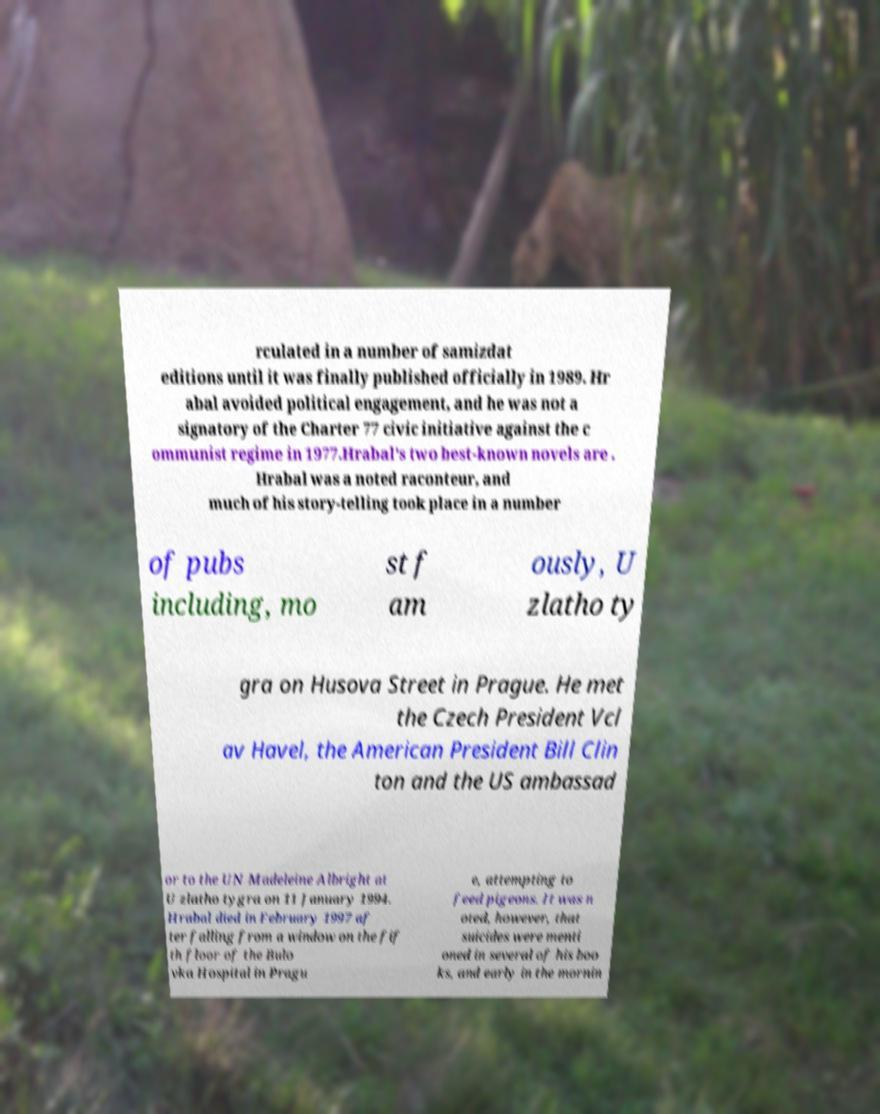Could you assist in decoding the text presented in this image and type it out clearly? rculated in a number of samizdat editions until it was finally published officially in 1989. Hr abal avoided political engagement, and he was not a signatory of the Charter 77 civic initiative against the c ommunist regime in 1977.Hrabal's two best-known novels are . Hrabal was a noted raconteur, and much of his story-telling took place in a number of pubs including, mo st f am ously, U zlatho ty gra on Husova Street in Prague. He met the Czech President Vcl av Havel, the American President Bill Clin ton and the US ambassad or to the UN Madeleine Albright at U zlatho tygra on 11 January 1994. Hrabal died in February 1997 af ter falling from a window on the fif th floor of the Bulo vka Hospital in Pragu e, attempting to feed pigeons. It was n oted, however, that suicides were menti oned in several of his boo ks, and early in the mornin 